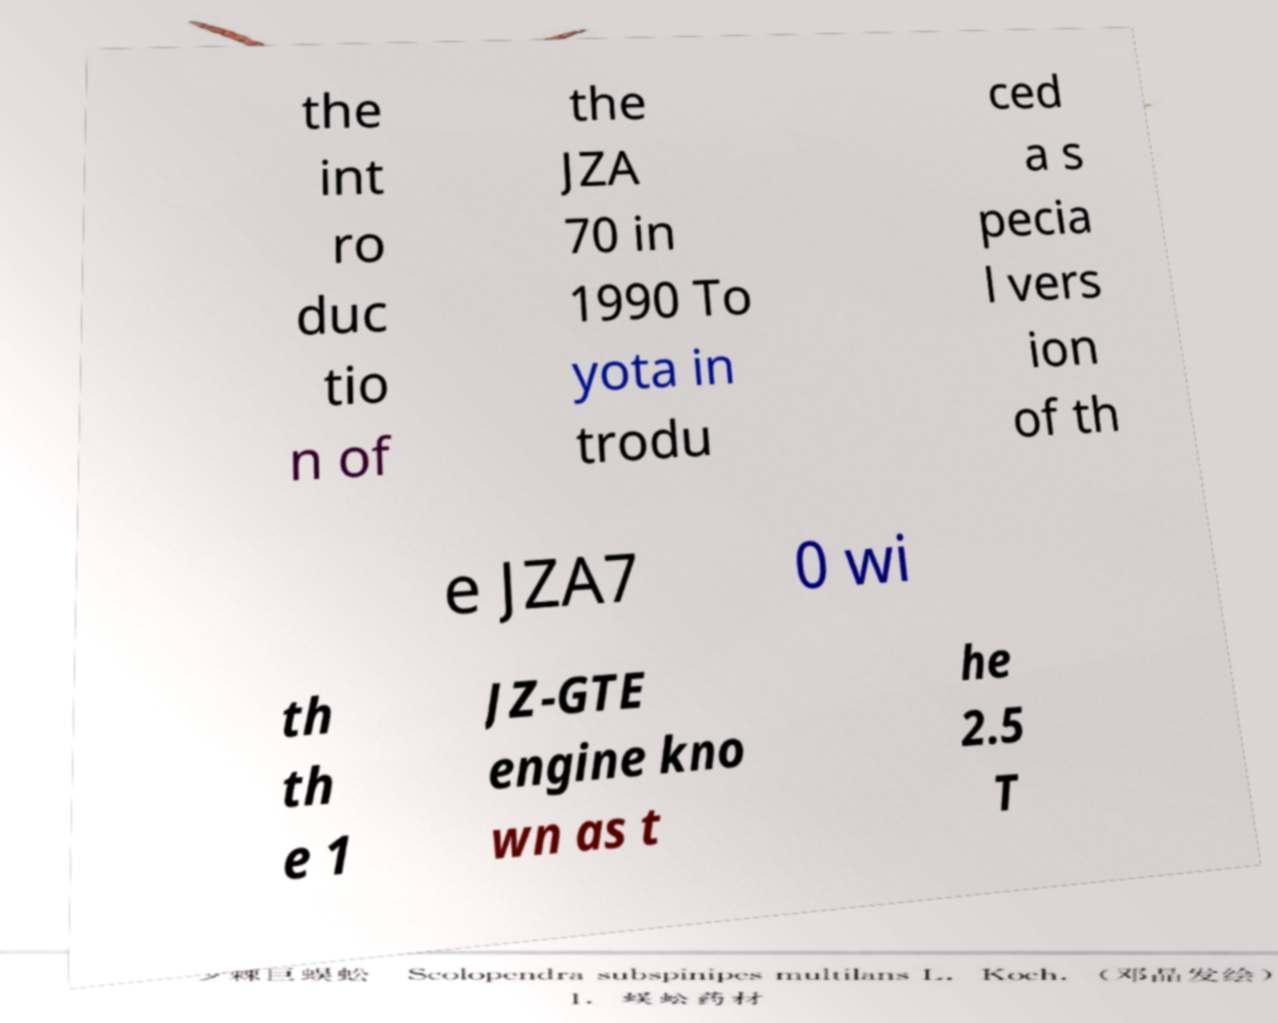What messages or text are displayed in this image? I need them in a readable, typed format. the int ro duc tio n of the JZA 70 in 1990 To yota in trodu ced a s pecia l vers ion of th e JZA7 0 wi th th e 1 JZ-GTE engine kno wn as t he 2.5 T 